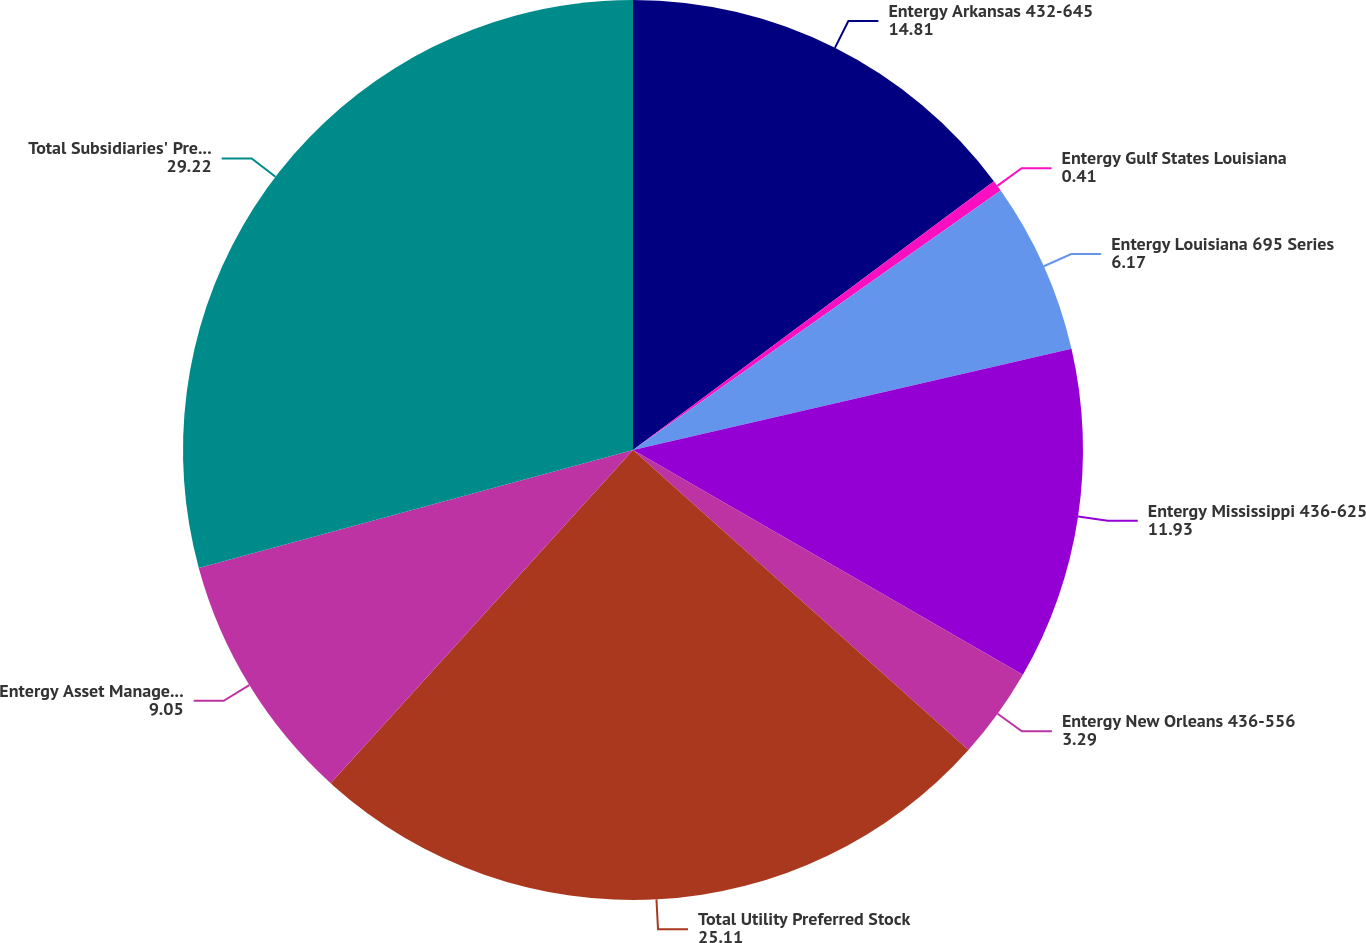<chart> <loc_0><loc_0><loc_500><loc_500><pie_chart><fcel>Entergy Arkansas 432-645<fcel>Entergy Gulf States Louisiana<fcel>Entergy Louisiana 695 Series<fcel>Entergy Mississippi 436-625<fcel>Entergy New Orleans 436-556<fcel>Total Utility Preferred Stock<fcel>Entergy Asset Management 895<fcel>Total Subsidiaries' Preferred<nl><fcel>14.81%<fcel>0.41%<fcel>6.17%<fcel>11.93%<fcel>3.29%<fcel>25.11%<fcel>9.05%<fcel>29.22%<nl></chart> 